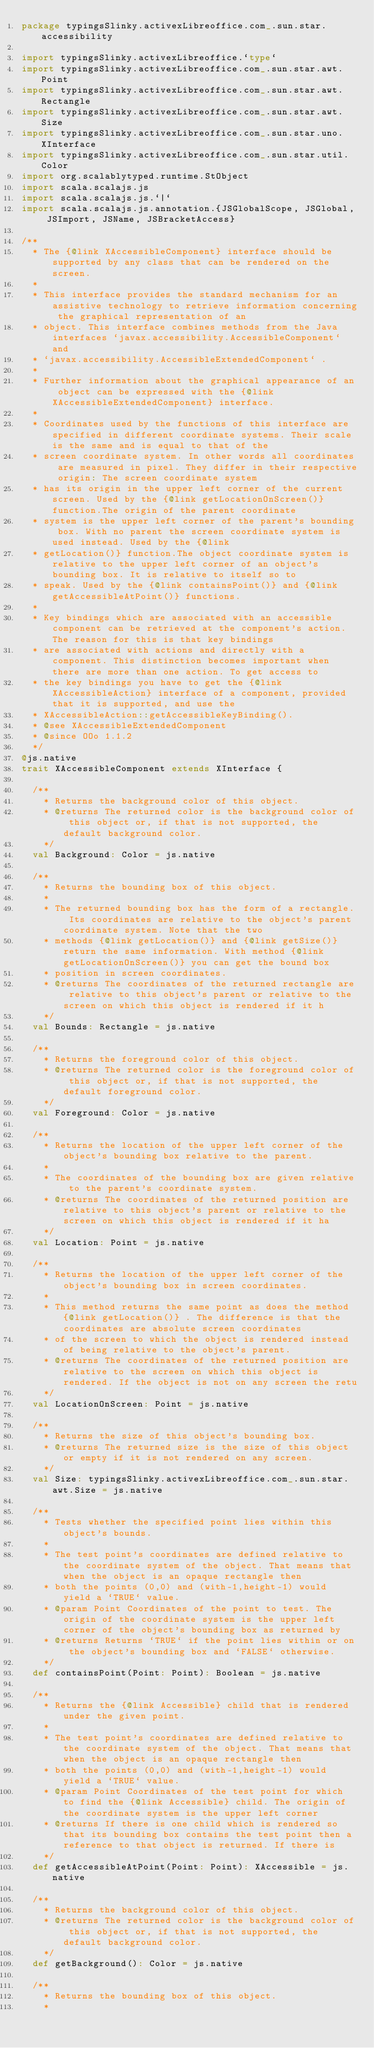Convert code to text. <code><loc_0><loc_0><loc_500><loc_500><_Scala_>package typingsSlinky.activexLibreoffice.com_.sun.star.accessibility

import typingsSlinky.activexLibreoffice.`type`
import typingsSlinky.activexLibreoffice.com_.sun.star.awt.Point
import typingsSlinky.activexLibreoffice.com_.sun.star.awt.Rectangle
import typingsSlinky.activexLibreoffice.com_.sun.star.awt.Size
import typingsSlinky.activexLibreoffice.com_.sun.star.uno.XInterface
import typingsSlinky.activexLibreoffice.com_.sun.star.util.Color
import org.scalablytyped.runtime.StObject
import scala.scalajs.js
import scala.scalajs.js.`|`
import scala.scalajs.js.annotation.{JSGlobalScope, JSGlobal, JSImport, JSName, JSBracketAccess}

/**
  * The {@link XAccessibleComponent} interface should be supported by any class that can be rendered on the screen.
  *
  * This interface provides the standard mechanism for an assistive technology to retrieve information concerning the graphical representation of an
  * object. This interface combines methods from the Java interfaces `javax.accessibility.AccessibleComponent` and
  * `javax.accessibility.AccessibleExtendedComponent` .
  *
  * Further information about the graphical appearance of an object can be expressed with the {@link XAccessibleExtendedComponent} interface.
  *
  * Coordinates used by the functions of this interface are specified in different coordinate systems. Their scale is the same and is equal to that of the
  * screen coordinate system. In other words all coordinates are measured in pixel. They differ in their respective origin: The screen coordinate system
  * has its origin in the upper left corner of the current screen. Used by the {@link getLocationOnScreen()} function.The origin of the parent coordinate
  * system is the upper left corner of the parent's bounding box. With no parent the screen coordinate system is used instead. Used by the {@link
  * getLocation()} function.The object coordinate system is relative to the upper left corner of an object's bounding box. It is relative to itself so to
  * speak. Used by the {@link containsPoint()} and {@link getAccessibleAtPoint()} functions.
  *
  * Key bindings which are associated with an accessible component can be retrieved at the component's action. The reason for this is that key bindings
  * are associated with actions and directly with a component. This distinction becomes important when there are more than one action. To get access to
  * the key bindings you have to get the {@link XAccessibleAction} interface of a component, provided that it is supported, and use the
  * XAccessibleAction::getAccessibleKeyBinding().
  * @see XAccessibleExtendedComponent
  * @since OOo 1.1.2
  */
@js.native
trait XAccessibleComponent extends XInterface {
  
  /**
    * Returns the background color of this object.
    * @returns The returned color is the background color of this object or, if that is not supported, the default background color.
    */
  val Background: Color = js.native
  
  /**
    * Returns the bounding box of this object.
    *
    * The returned bounding box has the form of a rectangle. Its coordinates are relative to the object's parent coordinate system. Note that the two
    * methods {@link getLocation()} and {@link getSize()} return the same information. With method {@link getLocationOnScreen()} you can get the bound box
    * position in screen coordinates.
    * @returns The coordinates of the returned rectangle are relative to this object's parent or relative to the screen on which this object is rendered if it h
    */
  val Bounds: Rectangle = js.native
  
  /**
    * Returns the foreground color of this object.
    * @returns The returned color is the foreground color of this object or, if that is not supported, the default foreground color.
    */
  val Foreground: Color = js.native
  
  /**
    * Returns the location of the upper left corner of the object's bounding box relative to the parent.
    *
    * The coordinates of the bounding box are given relative to the parent's coordinate system.
    * @returns The coordinates of the returned position are relative to this object's parent or relative to the screen on which this object is rendered if it ha
    */
  val Location: Point = js.native
  
  /**
    * Returns the location of the upper left corner of the object's bounding box in screen coordinates.
    *
    * This method returns the same point as does the method {@link getLocation()} . The difference is that the coordinates are absolute screen coordinates
    * of the screen to which the object is rendered instead of being relative to the object's parent.
    * @returns The coordinates of the returned position are relative to the screen on which this object is rendered. If the object is not on any screen the retu
    */
  val LocationOnScreen: Point = js.native
  
  /**
    * Returns the size of this object's bounding box.
    * @returns The returned size is the size of this object or empty if it is not rendered on any screen.
    */
  val Size: typingsSlinky.activexLibreoffice.com_.sun.star.awt.Size = js.native
  
  /**
    * Tests whether the specified point lies within this object's bounds.
    *
    * The test point's coordinates are defined relative to the coordinate system of the object. That means that when the object is an opaque rectangle then
    * both the points (0,0) and (with-1,height-1) would yield a `TRUE` value.
    * @param Point Coordinates of the point to test. The origin of the coordinate system is the upper left corner of the object's bounding box as returned by
    * @returns Returns `TRUE` if the point lies within or on the object's bounding box and `FALSE` otherwise.
    */
  def containsPoint(Point: Point): Boolean = js.native
  
  /**
    * Returns the {@link Accessible} child that is rendered under the given point.
    *
    * The test point's coordinates are defined relative to the coordinate system of the object. That means that when the object is an opaque rectangle then
    * both the points (0,0) and (with-1,height-1) would yield a `TRUE` value.
    * @param Point Coordinates of the test point for which to find the {@link Accessible} child. The origin of the coordinate system is the upper left corner
    * @returns If there is one child which is rendered so that its bounding box contains the test point then a reference to that object is returned. If there is
    */
  def getAccessibleAtPoint(Point: Point): XAccessible = js.native
  
  /**
    * Returns the background color of this object.
    * @returns The returned color is the background color of this object or, if that is not supported, the default background color.
    */
  def getBackground(): Color = js.native
  
  /**
    * Returns the bounding box of this object.
    *</code> 